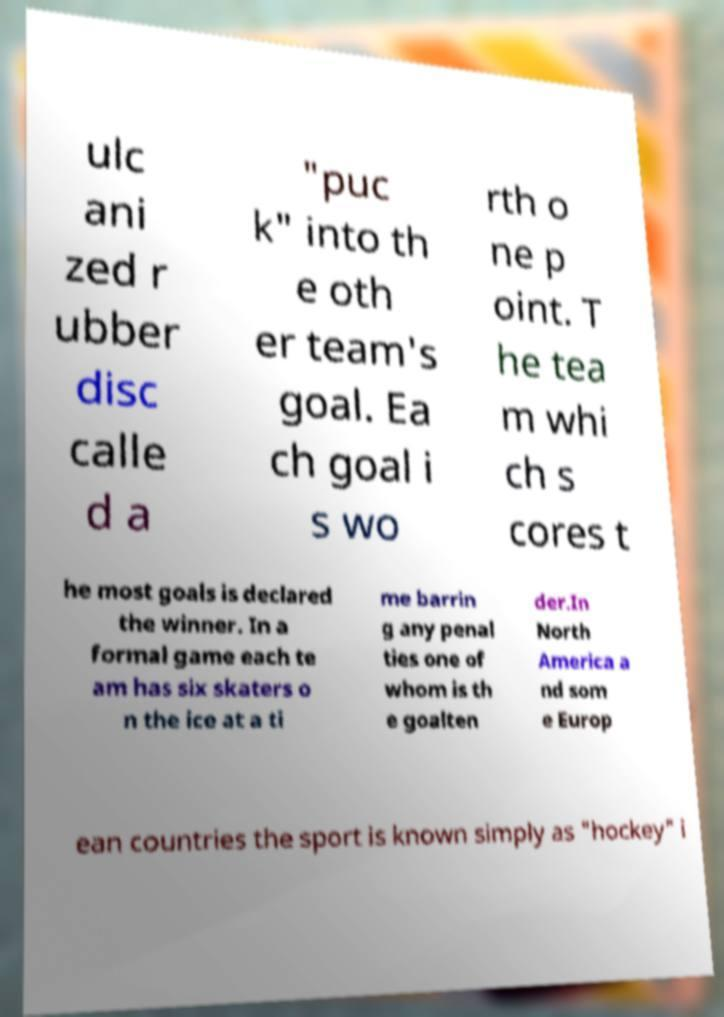There's text embedded in this image that I need extracted. Can you transcribe it verbatim? ulc ani zed r ubber disc calle d a "puc k" into th e oth er team's goal. Ea ch goal i s wo rth o ne p oint. T he tea m whi ch s cores t he most goals is declared the winner. In a formal game each te am has six skaters o n the ice at a ti me barrin g any penal ties one of whom is th e goalten der.In North America a nd som e Europ ean countries the sport is known simply as "hockey" i 